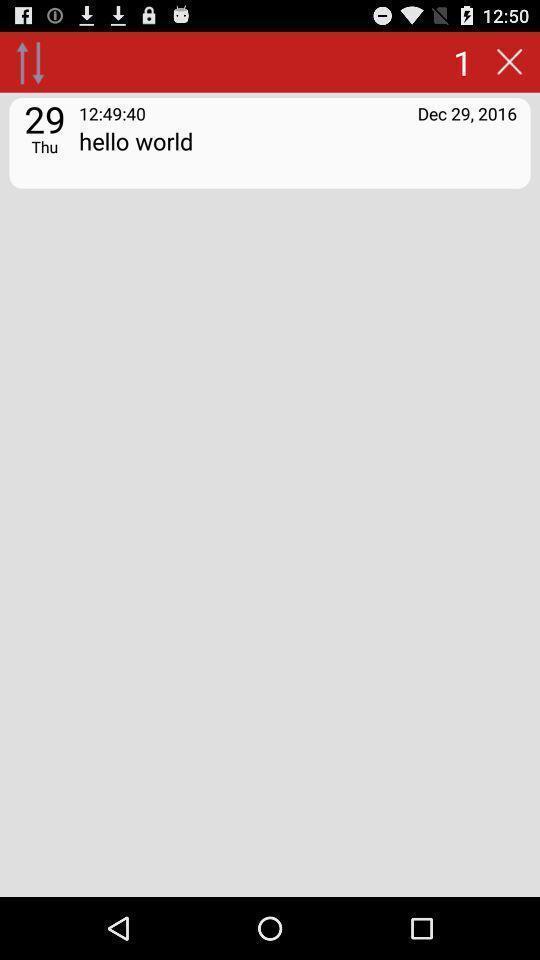Give me a summary of this screen capture. Screen showing a text message. 